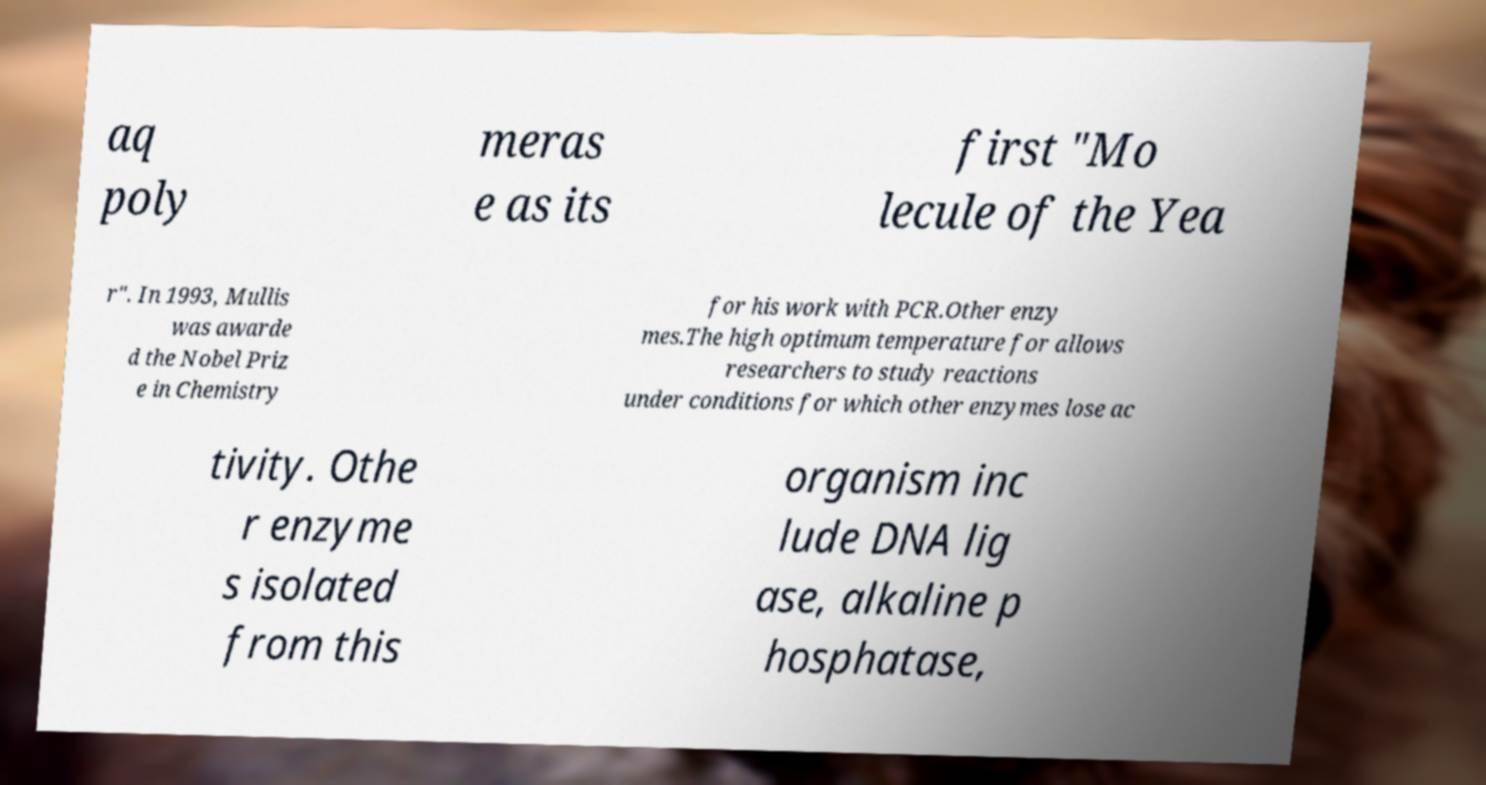There's text embedded in this image that I need extracted. Can you transcribe it verbatim? aq poly meras e as its first "Mo lecule of the Yea r". In 1993, Mullis was awarde d the Nobel Priz e in Chemistry for his work with PCR.Other enzy mes.The high optimum temperature for allows researchers to study reactions under conditions for which other enzymes lose ac tivity. Othe r enzyme s isolated from this organism inc lude DNA lig ase, alkaline p hosphatase, 